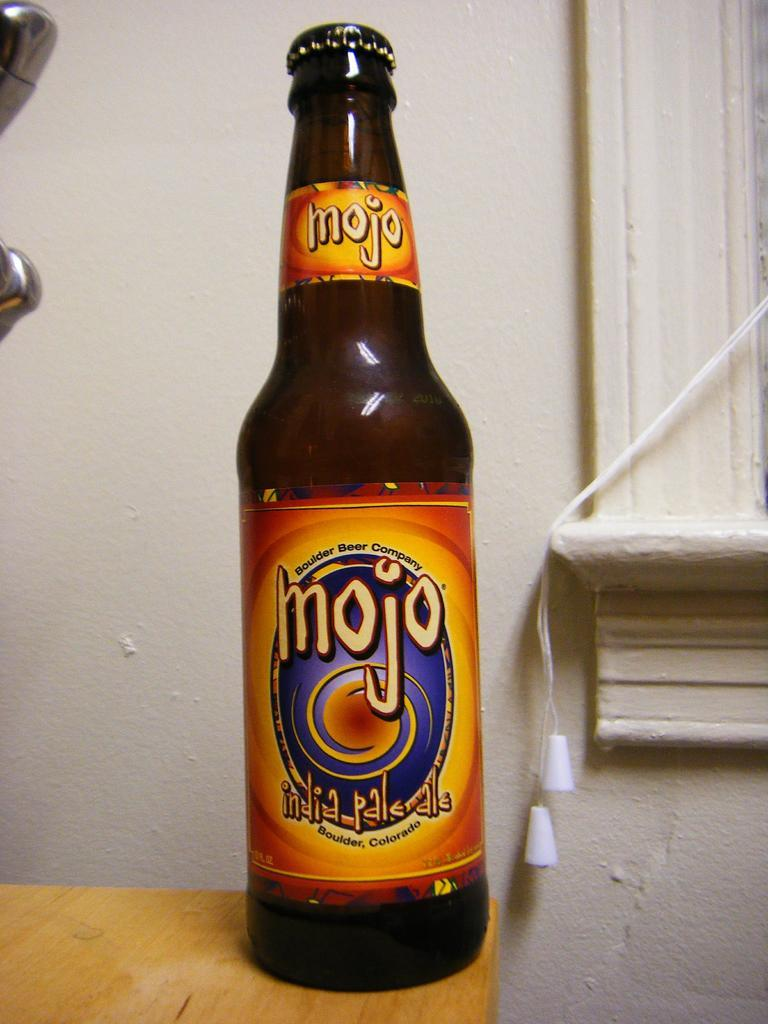What object can be seen in the image? There is a bottle in the image. Where is the bottle located? The bottle is placed on a wooden table. What can be seen in the background of the image? There is a wall in the background of the image. How does the crowd interact with the bottle in the image? There is no crowd present in the image, so it is not possible to answer how a crowd might interact with the bottle. 